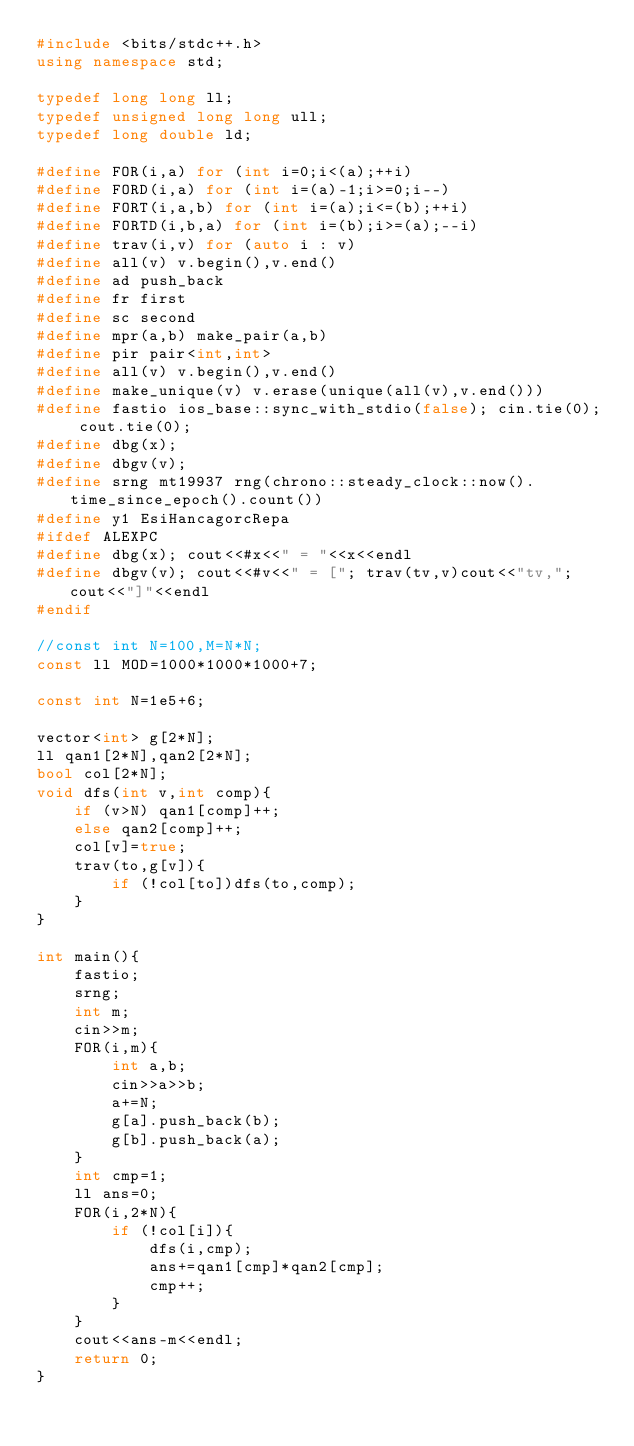<code> <loc_0><loc_0><loc_500><loc_500><_C++_>#include <bits/stdc++.h>
using namespace std;

typedef long long ll;
typedef unsigned long long ull;
typedef long double ld;

#define FOR(i,a) for (int i=0;i<(a);++i)
#define FORD(i,a) for (int i=(a)-1;i>=0;i--)
#define FORT(i,a,b) for (int i=(a);i<=(b);++i)
#define FORTD(i,b,a) for (int i=(b);i>=(a);--i)
#define trav(i,v) for (auto i : v)
#define all(v) v.begin(),v.end()
#define ad push_back
#define fr first
#define sc second
#define mpr(a,b) make_pair(a,b)
#define pir pair<int,int>
#define all(v) v.begin(),v.end()
#define make_unique(v) v.erase(unique(all(v),v.end()))
#define fastio ios_base::sync_with_stdio(false); cin.tie(0); cout.tie(0);
#define dbg(x);
#define dbgv(v);
#define srng mt19937 rng(chrono::steady_clock::now().time_since_epoch().count())
#define y1 EsiHancagorcRepa
#ifdef ALEXPC
#define dbg(x); cout<<#x<<" = "<<x<<endl
#define dbgv(v); cout<<#v<<" = ["; trav(tv,v)cout<<"tv,";cout<<"]"<<endl
#endif

//const int N=100,M=N*N;
const ll MOD=1000*1000*1000+7;

const int N=1e5+6;

vector<int> g[2*N];
ll qan1[2*N],qan2[2*N];
bool col[2*N];
void dfs(int v,int comp){
    if (v>N) qan1[comp]++;
    else qan2[comp]++;
    col[v]=true;
    trav(to,g[v]){
        if (!col[to])dfs(to,comp);
    }
}

int main(){
    fastio;
    srng;
    int m;
    cin>>m;
    FOR(i,m){
        int a,b;
        cin>>a>>b;
        a+=N;
        g[a].push_back(b);
        g[b].push_back(a);
    }
    int cmp=1;
    ll ans=0;
    FOR(i,2*N){
        if (!col[i]){
            dfs(i,cmp);
            ans+=qan1[cmp]*qan2[cmp];
            cmp++;
        }
    }
    cout<<ans-m<<endl;
    return 0;
}
</code> 